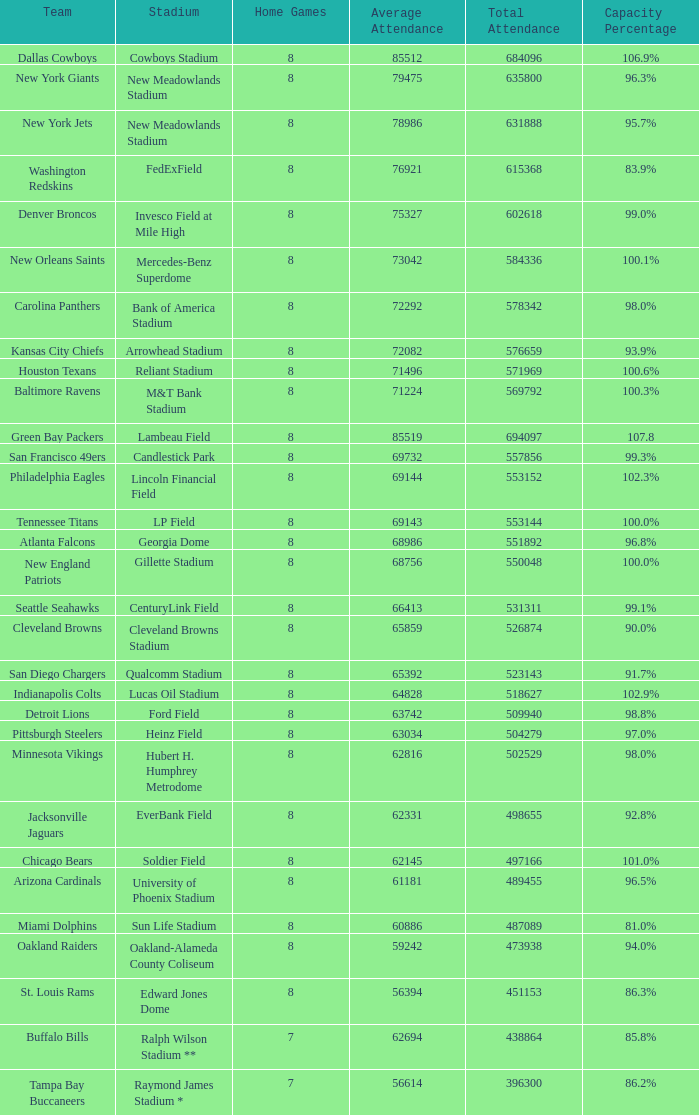What is the number listed in home games when the team is Seattle Seahawks? 8.0. 